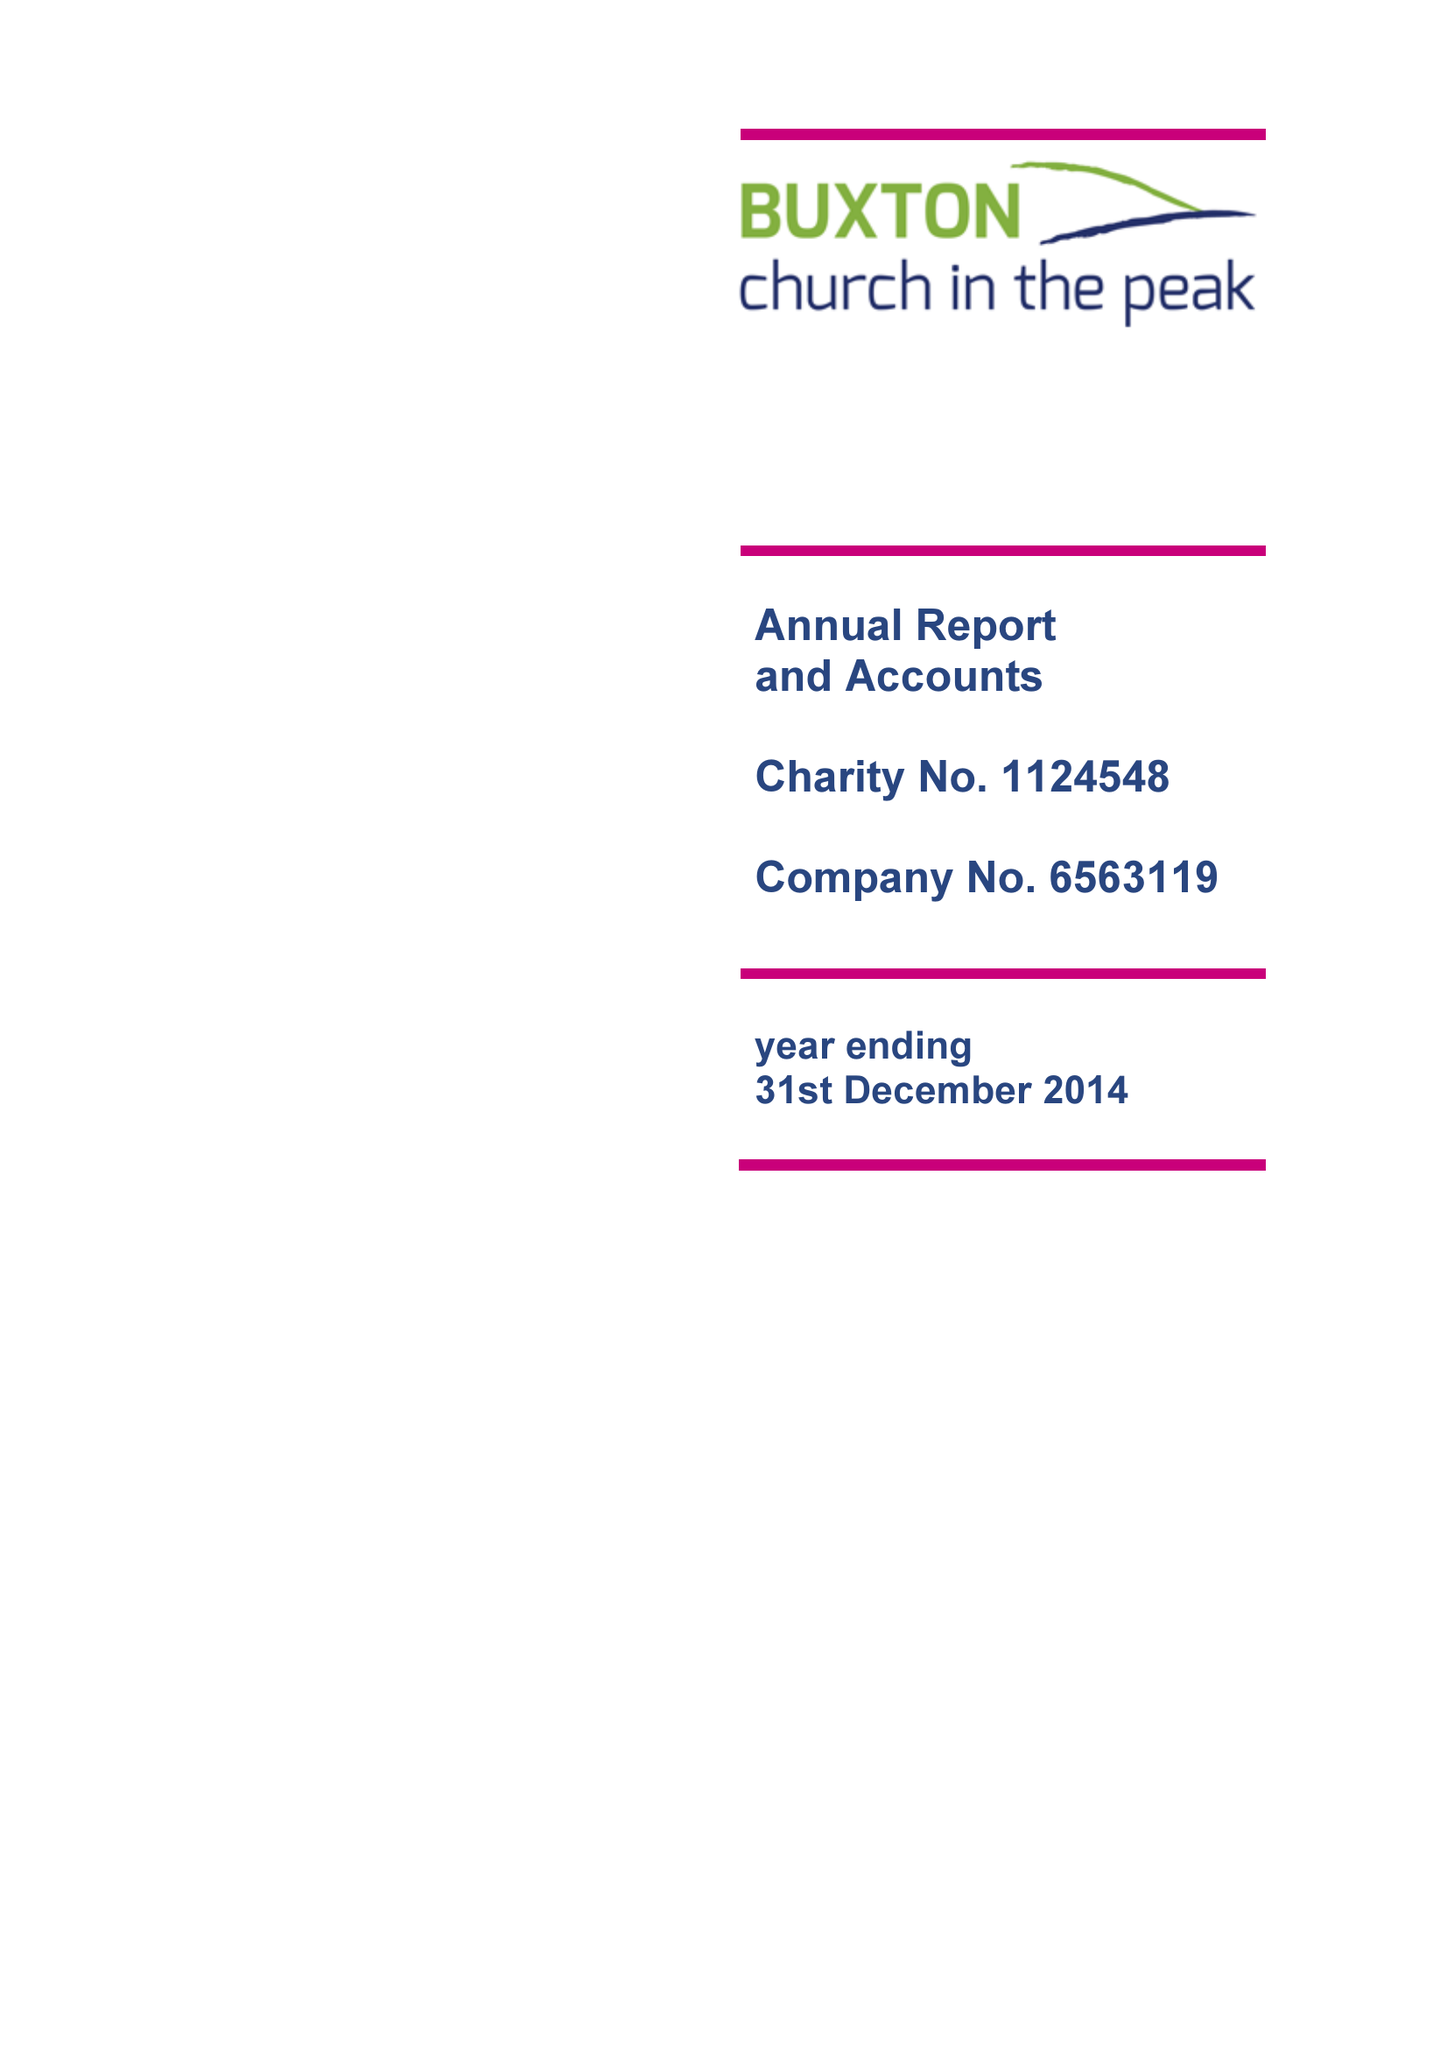What is the value for the address__street_line?
Answer the question using a single word or phrase. 116 MACCLESFIELD ROAD 